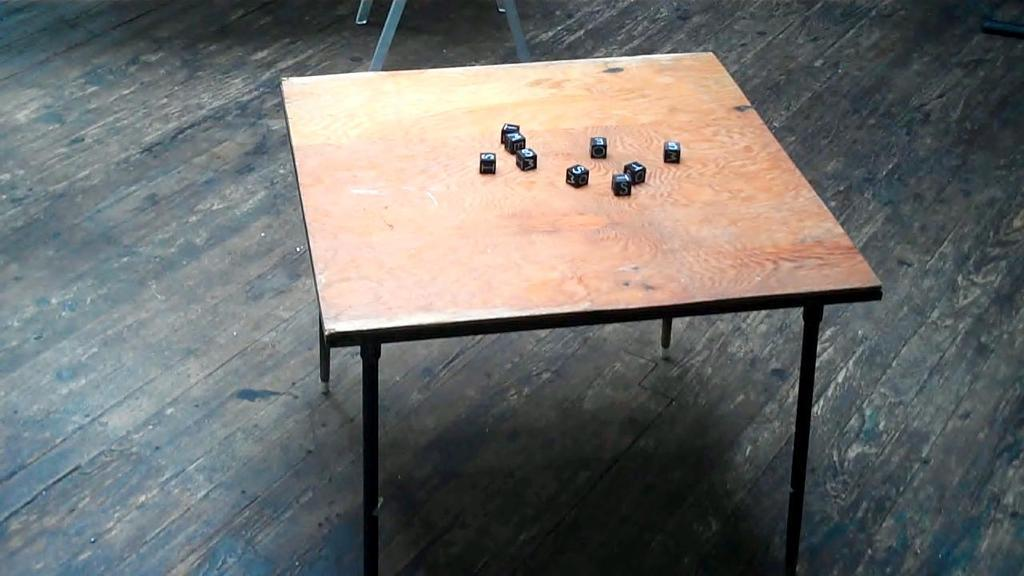What type of table is in the image? There is a wooden table in the image. What objects are on the table? There are alphabet dice on the table. What is the surface of the table made of? The table has a wooden surface. What else can be seen in the image besides the table and dice? There are rods visible in the image. What route do the alphabet dice take to reach the rods in the image? There is no indication of movement or a route in the image; the dice and rods are stationary. 